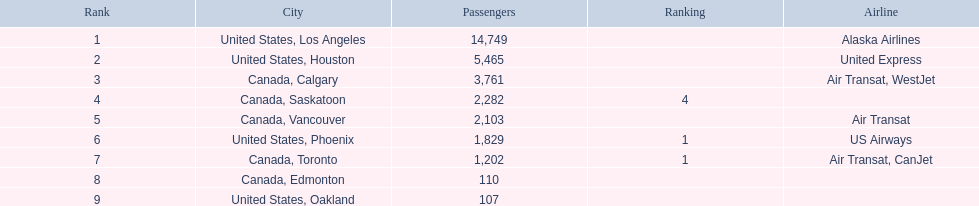Which locations does the airport serve? United States, Los Angeles, United States, Houston, Canada, Calgary, Canada, Saskatoon, Canada, Vancouver, United States, Phoenix, Canada, Toronto, Canada, Edmonton, United States, Oakland. What's the passenger count for phoenix? 1,829. 